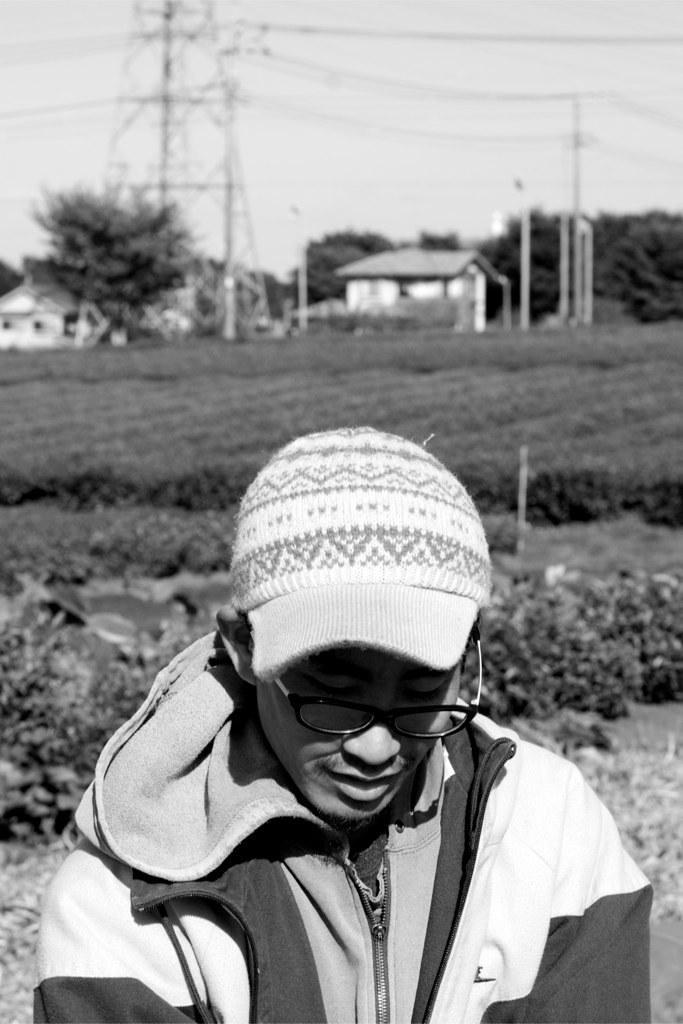In one or two sentences, can you explain what this image depicts? In this image I can see a person standing wearing cap and jacket. Background I can see few houses, trees, electric poles and sky. The image is in black and white. 